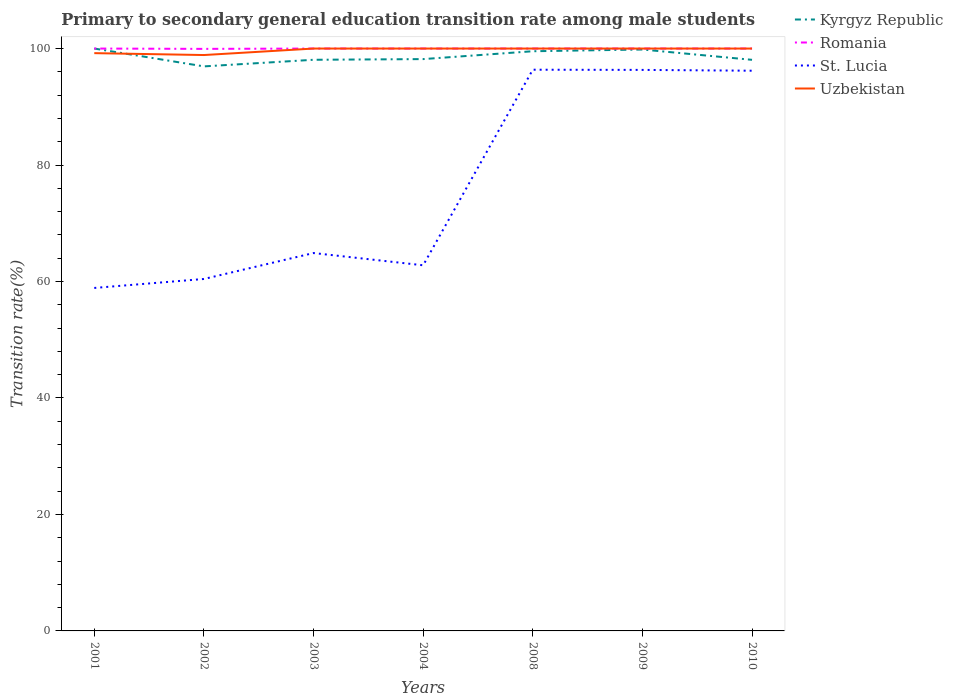Does the line corresponding to Romania intersect with the line corresponding to Kyrgyz Republic?
Give a very brief answer. Yes. Across all years, what is the maximum transition rate in Uzbekistan?
Provide a succinct answer. 98.88. In which year was the transition rate in Kyrgyz Republic maximum?
Ensure brevity in your answer.  2002. What is the total transition rate in Kyrgyz Republic in the graph?
Your answer should be very brief. 1.81. What is the difference between the highest and the second highest transition rate in Kyrgyz Republic?
Provide a short and direct response. 3.06. Is the transition rate in Uzbekistan strictly greater than the transition rate in Romania over the years?
Provide a short and direct response. No. How many lines are there?
Offer a very short reply. 4. How many years are there in the graph?
Make the answer very short. 7. Does the graph contain any zero values?
Keep it short and to the point. No. Does the graph contain grids?
Keep it short and to the point. No. Where does the legend appear in the graph?
Provide a short and direct response. Top right. How are the legend labels stacked?
Provide a short and direct response. Vertical. What is the title of the graph?
Offer a very short reply. Primary to secondary general education transition rate among male students. What is the label or title of the Y-axis?
Provide a succinct answer. Transition rate(%). What is the Transition rate(%) in Kyrgyz Republic in 2001?
Provide a short and direct response. 100. What is the Transition rate(%) in St. Lucia in 2001?
Provide a short and direct response. 58.89. What is the Transition rate(%) in Uzbekistan in 2001?
Your response must be concise. 99.21. What is the Transition rate(%) of Kyrgyz Republic in 2002?
Offer a very short reply. 96.94. What is the Transition rate(%) in Romania in 2002?
Your answer should be compact. 99.94. What is the Transition rate(%) in St. Lucia in 2002?
Provide a short and direct response. 60.43. What is the Transition rate(%) in Uzbekistan in 2002?
Give a very brief answer. 98.88. What is the Transition rate(%) in Kyrgyz Republic in 2003?
Keep it short and to the point. 98.07. What is the Transition rate(%) in Romania in 2003?
Your answer should be compact. 100. What is the Transition rate(%) of St. Lucia in 2003?
Provide a short and direct response. 64.89. What is the Transition rate(%) in Uzbekistan in 2003?
Keep it short and to the point. 100. What is the Transition rate(%) in Kyrgyz Republic in 2004?
Give a very brief answer. 98.19. What is the Transition rate(%) of Romania in 2004?
Your answer should be very brief. 100. What is the Transition rate(%) in St. Lucia in 2004?
Make the answer very short. 62.78. What is the Transition rate(%) of Uzbekistan in 2004?
Make the answer very short. 100. What is the Transition rate(%) of Kyrgyz Republic in 2008?
Your response must be concise. 99.54. What is the Transition rate(%) in St. Lucia in 2008?
Keep it short and to the point. 96.37. What is the Transition rate(%) in Uzbekistan in 2008?
Your answer should be compact. 100. What is the Transition rate(%) of Kyrgyz Republic in 2009?
Make the answer very short. 99.83. What is the Transition rate(%) of St. Lucia in 2009?
Your response must be concise. 96.33. What is the Transition rate(%) in Uzbekistan in 2009?
Your response must be concise. 100. What is the Transition rate(%) of Kyrgyz Republic in 2010?
Your answer should be compact. 98.06. What is the Transition rate(%) in Romania in 2010?
Provide a succinct answer. 100. What is the Transition rate(%) in St. Lucia in 2010?
Give a very brief answer. 96.19. What is the Transition rate(%) of Uzbekistan in 2010?
Make the answer very short. 100. Across all years, what is the maximum Transition rate(%) in Romania?
Your response must be concise. 100. Across all years, what is the maximum Transition rate(%) in St. Lucia?
Give a very brief answer. 96.37. Across all years, what is the maximum Transition rate(%) of Uzbekistan?
Your answer should be very brief. 100. Across all years, what is the minimum Transition rate(%) of Kyrgyz Republic?
Provide a short and direct response. 96.94. Across all years, what is the minimum Transition rate(%) in Romania?
Offer a very short reply. 99.94. Across all years, what is the minimum Transition rate(%) in St. Lucia?
Your answer should be compact. 58.89. Across all years, what is the minimum Transition rate(%) of Uzbekistan?
Keep it short and to the point. 98.88. What is the total Transition rate(%) in Kyrgyz Republic in the graph?
Make the answer very short. 690.63. What is the total Transition rate(%) of Romania in the graph?
Provide a succinct answer. 699.94. What is the total Transition rate(%) of St. Lucia in the graph?
Your answer should be very brief. 535.89. What is the total Transition rate(%) of Uzbekistan in the graph?
Make the answer very short. 698.1. What is the difference between the Transition rate(%) of Kyrgyz Republic in 2001 and that in 2002?
Your answer should be compact. 3.06. What is the difference between the Transition rate(%) in Romania in 2001 and that in 2002?
Your answer should be compact. 0.06. What is the difference between the Transition rate(%) in St. Lucia in 2001 and that in 2002?
Give a very brief answer. -1.54. What is the difference between the Transition rate(%) of Uzbekistan in 2001 and that in 2002?
Keep it short and to the point. 0.33. What is the difference between the Transition rate(%) in Kyrgyz Republic in 2001 and that in 2003?
Keep it short and to the point. 1.93. What is the difference between the Transition rate(%) in Romania in 2001 and that in 2003?
Your answer should be very brief. 0. What is the difference between the Transition rate(%) of St. Lucia in 2001 and that in 2003?
Provide a succinct answer. -5.99. What is the difference between the Transition rate(%) of Uzbekistan in 2001 and that in 2003?
Your response must be concise. -0.79. What is the difference between the Transition rate(%) in Kyrgyz Republic in 2001 and that in 2004?
Provide a short and direct response. 1.81. What is the difference between the Transition rate(%) of St. Lucia in 2001 and that in 2004?
Offer a very short reply. -3.89. What is the difference between the Transition rate(%) of Uzbekistan in 2001 and that in 2004?
Your response must be concise. -0.79. What is the difference between the Transition rate(%) of Kyrgyz Republic in 2001 and that in 2008?
Offer a terse response. 0.46. What is the difference between the Transition rate(%) of St. Lucia in 2001 and that in 2008?
Your answer should be compact. -37.47. What is the difference between the Transition rate(%) in Uzbekistan in 2001 and that in 2008?
Your answer should be very brief. -0.79. What is the difference between the Transition rate(%) in Kyrgyz Republic in 2001 and that in 2009?
Your answer should be very brief. 0.17. What is the difference between the Transition rate(%) in Romania in 2001 and that in 2009?
Provide a succinct answer. 0. What is the difference between the Transition rate(%) of St. Lucia in 2001 and that in 2009?
Make the answer very short. -37.44. What is the difference between the Transition rate(%) in Uzbekistan in 2001 and that in 2009?
Your answer should be compact. -0.79. What is the difference between the Transition rate(%) of Kyrgyz Republic in 2001 and that in 2010?
Offer a very short reply. 1.94. What is the difference between the Transition rate(%) in Romania in 2001 and that in 2010?
Your response must be concise. 0. What is the difference between the Transition rate(%) in St. Lucia in 2001 and that in 2010?
Offer a very short reply. -37.3. What is the difference between the Transition rate(%) of Uzbekistan in 2001 and that in 2010?
Your answer should be compact. -0.79. What is the difference between the Transition rate(%) in Kyrgyz Republic in 2002 and that in 2003?
Provide a short and direct response. -1.13. What is the difference between the Transition rate(%) of Romania in 2002 and that in 2003?
Make the answer very short. -0.06. What is the difference between the Transition rate(%) of St. Lucia in 2002 and that in 2003?
Make the answer very short. -4.45. What is the difference between the Transition rate(%) in Uzbekistan in 2002 and that in 2003?
Provide a succinct answer. -1.12. What is the difference between the Transition rate(%) in Kyrgyz Republic in 2002 and that in 2004?
Make the answer very short. -1.25. What is the difference between the Transition rate(%) in Romania in 2002 and that in 2004?
Offer a very short reply. -0.06. What is the difference between the Transition rate(%) of St. Lucia in 2002 and that in 2004?
Provide a short and direct response. -2.35. What is the difference between the Transition rate(%) in Uzbekistan in 2002 and that in 2004?
Provide a short and direct response. -1.12. What is the difference between the Transition rate(%) in Kyrgyz Republic in 2002 and that in 2008?
Offer a terse response. -2.6. What is the difference between the Transition rate(%) of Romania in 2002 and that in 2008?
Make the answer very short. -0.06. What is the difference between the Transition rate(%) in St. Lucia in 2002 and that in 2008?
Provide a succinct answer. -35.93. What is the difference between the Transition rate(%) of Uzbekistan in 2002 and that in 2008?
Give a very brief answer. -1.12. What is the difference between the Transition rate(%) in Kyrgyz Republic in 2002 and that in 2009?
Ensure brevity in your answer.  -2.9. What is the difference between the Transition rate(%) in Romania in 2002 and that in 2009?
Offer a very short reply. -0.06. What is the difference between the Transition rate(%) of St. Lucia in 2002 and that in 2009?
Provide a short and direct response. -35.9. What is the difference between the Transition rate(%) of Uzbekistan in 2002 and that in 2009?
Give a very brief answer. -1.12. What is the difference between the Transition rate(%) of Kyrgyz Republic in 2002 and that in 2010?
Ensure brevity in your answer.  -1.13. What is the difference between the Transition rate(%) in Romania in 2002 and that in 2010?
Your answer should be very brief. -0.06. What is the difference between the Transition rate(%) of St. Lucia in 2002 and that in 2010?
Keep it short and to the point. -35.76. What is the difference between the Transition rate(%) of Uzbekistan in 2002 and that in 2010?
Give a very brief answer. -1.12. What is the difference between the Transition rate(%) of Kyrgyz Republic in 2003 and that in 2004?
Make the answer very short. -0.12. What is the difference between the Transition rate(%) in Romania in 2003 and that in 2004?
Make the answer very short. 0. What is the difference between the Transition rate(%) of St. Lucia in 2003 and that in 2004?
Provide a short and direct response. 2.1. What is the difference between the Transition rate(%) in Kyrgyz Republic in 2003 and that in 2008?
Provide a short and direct response. -1.47. What is the difference between the Transition rate(%) of St. Lucia in 2003 and that in 2008?
Keep it short and to the point. -31.48. What is the difference between the Transition rate(%) in Kyrgyz Republic in 2003 and that in 2009?
Your answer should be very brief. -1.76. What is the difference between the Transition rate(%) in St. Lucia in 2003 and that in 2009?
Offer a very short reply. -31.45. What is the difference between the Transition rate(%) of Uzbekistan in 2003 and that in 2009?
Your response must be concise. 0. What is the difference between the Transition rate(%) in Kyrgyz Republic in 2003 and that in 2010?
Provide a succinct answer. 0.01. What is the difference between the Transition rate(%) of Romania in 2003 and that in 2010?
Keep it short and to the point. 0. What is the difference between the Transition rate(%) of St. Lucia in 2003 and that in 2010?
Make the answer very short. -31.31. What is the difference between the Transition rate(%) of Uzbekistan in 2003 and that in 2010?
Keep it short and to the point. 0. What is the difference between the Transition rate(%) in Kyrgyz Republic in 2004 and that in 2008?
Your answer should be very brief. -1.35. What is the difference between the Transition rate(%) in Romania in 2004 and that in 2008?
Offer a terse response. 0. What is the difference between the Transition rate(%) in St. Lucia in 2004 and that in 2008?
Offer a terse response. -33.58. What is the difference between the Transition rate(%) in Kyrgyz Republic in 2004 and that in 2009?
Your response must be concise. -1.65. What is the difference between the Transition rate(%) of St. Lucia in 2004 and that in 2009?
Your answer should be very brief. -33.55. What is the difference between the Transition rate(%) in Kyrgyz Republic in 2004 and that in 2010?
Your response must be concise. 0.12. What is the difference between the Transition rate(%) of St. Lucia in 2004 and that in 2010?
Provide a succinct answer. -33.41. What is the difference between the Transition rate(%) in Kyrgyz Republic in 2008 and that in 2009?
Offer a very short reply. -0.3. What is the difference between the Transition rate(%) in Romania in 2008 and that in 2009?
Your response must be concise. 0. What is the difference between the Transition rate(%) of St. Lucia in 2008 and that in 2009?
Keep it short and to the point. 0.03. What is the difference between the Transition rate(%) of Uzbekistan in 2008 and that in 2009?
Ensure brevity in your answer.  0. What is the difference between the Transition rate(%) in Kyrgyz Republic in 2008 and that in 2010?
Make the answer very short. 1.47. What is the difference between the Transition rate(%) of St. Lucia in 2008 and that in 2010?
Your answer should be very brief. 0.17. What is the difference between the Transition rate(%) of Uzbekistan in 2008 and that in 2010?
Offer a very short reply. 0. What is the difference between the Transition rate(%) in Kyrgyz Republic in 2009 and that in 2010?
Offer a very short reply. 1.77. What is the difference between the Transition rate(%) in St. Lucia in 2009 and that in 2010?
Keep it short and to the point. 0.14. What is the difference between the Transition rate(%) in Uzbekistan in 2009 and that in 2010?
Offer a very short reply. 0. What is the difference between the Transition rate(%) in Kyrgyz Republic in 2001 and the Transition rate(%) in Romania in 2002?
Offer a terse response. 0.06. What is the difference between the Transition rate(%) of Kyrgyz Republic in 2001 and the Transition rate(%) of St. Lucia in 2002?
Your answer should be compact. 39.57. What is the difference between the Transition rate(%) of Kyrgyz Republic in 2001 and the Transition rate(%) of Uzbekistan in 2002?
Give a very brief answer. 1.12. What is the difference between the Transition rate(%) in Romania in 2001 and the Transition rate(%) in St. Lucia in 2002?
Give a very brief answer. 39.57. What is the difference between the Transition rate(%) in Romania in 2001 and the Transition rate(%) in Uzbekistan in 2002?
Provide a short and direct response. 1.12. What is the difference between the Transition rate(%) of St. Lucia in 2001 and the Transition rate(%) of Uzbekistan in 2002?
Your answer should be very brief. -39.99. What is the difference between the Transition rate(%) of Kyrgyz Republic in 2001 and the Transition rate(%) of Romania in 2003?
Your response must be concise. 0. What is the difference between the Transition rate(%) of Kyrgyz Republic in 2001 and the Transition rate(%) of St. Lucia in 2003?
Provide a succinct answer. 35.11. What is the difference between the Transition rate(%) of Kyrgyz Republic in 2001 and the Transition rate(%) of Uzbekistan in 2003?
Provide a short and direct response. 0. What is the difference between the Transition rate(%) in Romania in 2001 and the Transition rate(%) in St. Lucia in 2003?
Make the answer very short. 35.11. What is the difference between the Transition rate(%) in Romania in 2001 and the Transition rate(%) in Uzbekistan in 2003?
Your response must be concise. 0. What is the difference between the Transition rate(%) of St. Lucia in 2001 and the Transition rate(%) of Uzbekistan in 2003?
Your response must be concise. -41.11. What is the difference between the Transition rate(%) in Kyrgyz Republic in 2001 and the Transition rate(%) in St. Lucia in 2004?
Your answer should be compact. 37.22. What is the difference between the Transition rate(%) in Kyrgyz Republic in 2001 and the Transition rate(%) in Uzbekistan in 2004?
Offer a very short reply. 0. What is the difference between the Transition rate(%) in Romania in 2001 and the Transition rate(%) in St. Lucia in 2004?
Your response must be concise. 37.22. What is the difference between the Transition rate(%) of Romania in 2001 and the Transition rate(%) of Uzbekistan in 2004?
Your response must be concise. 0. What is the difference between the Transition rate(%) of St. Lucia in 2001 and the Transition rate(%) of Uzbekistan in 2004?
Make the answer very short. -41.11. What is the difference between the Transition rate(%) in Kyrgyz Republic in 2001 and the Transition rate(%) in Romania in 2008?
Ensure brevity in your answer.  0. What is the difference between the Transition rate(%) of Kyrgyz Republic in 2001 and the Transition rate(%) of St. Lucia in 2008?
Offer a very short reply. 3.63. What is the difference between the Transition rate(%) of Kyrgyz Republic in 2001 and the Transition rate(%) of Uzbekistan in 2008?
Your answer should be compact. 0. What is the difference between the Transition rate(%) of Romania in 2001 and the Transition rate(%) of St. Lucia in 2008?
Your response must be concise. 3.63. What is the difference between the Transition rate(%) in Romania in 2001 and the Transition rate(%) in Uzbekistan in 2008?
Offer a terse response. 0. What is the difference between the Transition rate(%) of St. Lucia in 2001 and the Transition rate(%) of Uzbekistan in 2008?
Provide a short and direct response. -41.11. What is the difference between the Transition rate(%) of Kyrgyz Republic in 2001 and the Transition rate(%) of Romania in 2009?
Give a very brief answer. 0. What is the difference between the Transition rate(%) in Kyrgyz Republic in 2001 and the Transition rate(%) in St. Lucia in 2009?
Give a very brief answer. 3.67. What is the difference between the Transition rate(%) in Romania in 2001 and the Transition rate(%) in St. Lucia in 2009?
Give a very brief answer. 3.67. What is the difference between the Transition rate(%) of St. Lucia in 2001 and the Transition rate(%) of Uzbekistan in 2009?
Provide a short and direct response. -41.11. What is the difference between the Transition rate(%) in Kyrgyz Republic in 2001 and the Transition rate(%) in Romania in 2010?
Ensure brevity in your answer.  0. What is the difference between the Transition rate(%) in Kyrgyz Republic in 2001 and the Transition rate(%) in St. Lucia in 2010?
Provide a short and direct response. 3.81. What is the difference between the Transition rate(%) in Romania in 2001 and the Transition rate(%) in St. Lucia in 2010?
Your response must be concise. 3.81. What is the difference between the Transition rate(%) in St. Lucia in 2001 and the Transition rate(%) in Uzbekistan in 2010?
Your answer should be very brief. -41.11. What is the difference between the Transition rate(%) of Kyrgyz Republic in 2002 and the Transition rate(%) of Romania in 2003?
Make the answer very short. -3.06. What is the difference between the Transition rate(%) in Kyrgyz Republic in 2002 and the Transition rate(%) in St. Lucia in 2003?
Your response must be concise. 32.05. What is the difference between the Transition rate(%) in Kyrgyz Republic in 2002 and the Transition rate(%) in Uzbekistan in 2003?
Keep it short and to the point. -3.06. What is the difference between the Transition rate(%) in Romania in 2002 and the Transition rate(%) in St. Lucia in 2003?
Your response must be concise. 35.06. What is the difference between the Transition rate(%) in Romania in 2002 and the Transition rate(%) in Uzbekistan in 2003?
Your response must be concise. -0.06. What is the difference between the Transition rate(%) of St. Lucia in 2002 and the Transition rate(%) of Uzbekistan in 2003?
Give a very brief answer. -39.57. What is the difference between the Transition rate(%) in Kyrgyz Republic in 2002 and the Transition rate(%) in Romania in 2004?
Offer a very short reply. -3.06. What is the difference between the Transition rate(%) of Kyrgyz Republic in 2002 and the Transition rate(%) of St. Lucia in 2004?
Offer a terse response. 34.15. What is the difference between the Transition rate(%) in Kyrgyz Republic in 2002 and the Transition rate(%) in Uzbekistan in 2004?
Make the answer very short. -3.06. What is the difference between the Transition rate(%) of Romania in 2002 and the Transition rate(%) of St. Lucia in 2004?
Offer a very short reply. 37.16. What is the difference between the Transition rate(%) in Romania in 2002 and the Transition rate(%) in Uzbekistan in 2004?
Give a very brief answer. -0.06. What is the difference between the Transition rate(%) in St. Lucia in 2002 and the Transition rate(%) in Uzbekistan in 2004?
Your response must be concise. -39.57. What is the difference between the Transition rate(%) of Kyrgyz Republic in 2002 and the Transition rate(%) of Romania in 2008?
Ensure brevity in your answer.  -3.06. What is the difference between the Transition rate(%) in Kyrgyz Republic in 2002 and the Transition rate(%) in St. Lucia in 2008?
Offer a terse response. 0.57. What is the difference between the Transition rate(%) of Kyrgyz Republic in 2002 and the Transition rate(%) of Uzbekistan in 2008?
Offer a very short reply. -3.06. What is the difference between the Transition rate(%) in Romania in 2002 and the Transition rate(%) in St. Lucia in 2008?
Your answer should be compact. 3.58. What is the difference between the Transition rate(%) in Romania in 2002 and the Transition rate(%) in Uzbekistan in 2008?
Your response must be concise. -0.06. What is the difference between the Transition rate(%) of St. Lucia in 2002 and the Transition rate(%) of Uzbekistan in 2008?
Offer a terse response. -39.57. What is the difference between the Transition rate(%) of Kyrgyz Republic in 2002 and the Transition rate(%) of Romania in 2009?
Provide a short and direct response. -3.06. What is the difference between the Transition rate(%) in Kyrgyz Republic in 2002 and the Transition rate(%) in St. Lucia in 2009?
Provide a short and direct response. 0.6. What is the difference between the Transition rate(%) of Kyrgyz Republic in 2002 and the Transition rate(%) of Uzbekistan in 2009?
Provide a succinct answer. -3.06. What is the difference between the Transition rate(%) of Romania in 2002 and the Transition rate(%) of St. Lucia in 2009?
Offer a very short reply. 3.61. What is the difference between the Transition rate(%) in Romania in 2002 and the Transition rate(%) in Uzbekistan in 2009?
Provide a succinct answer. -0.06. What is the difference between the Transition rate(%) of St. Lucia in 2002 and the Transition rate(%) of Uzbekistan in 2009?
Your answer should be compact. -39.57. What is the difference between the Transition rate(%) of Kyrgyz Republic in 2002 and the Transition rate(%) of Romania in 2010?
Offer a very short reply. -3.06. What is the difference between the Transition rate(%) in Kyrgyz Republic in 2002 and the Transition rate(%) in St. Lucia in 2010?
Give a very brief answer. 0.74. What is the difference between the Transition rate(%) in Kyrgyz Republic in 2002 and the Transition rate(%) in Uzbekistan in 2010?
Your answer should be very brief. -3.06. What is the difference between the Transition rate(%) of Romania in 2002 and the Transition rate(%) of St. Lucia in 2010?
Your answer should be compact. 3.75. What is the difference between the Transition rate(%) of Romania in 2002 and the Transition rate(%) of Uzbekistan in 2010?
Give a very brief answer. -0.06. What is the difference between the Transition rate(%) of St. Lucia in 2002 and the Transition rate(%) of Uzbekistan in 2010?
Offer a terse response. -39.57. What is the difference between the Transition rate(%) of Kyrgyz Republic in 2003 and the Transition rate(%) of Romania in 2004?
Offer a very short reply. -1.93. What is the difference between the Transition rate(%) in Kyrgyz Republic in 2003 and the Transition rate(%) in St. Lucia in 2004?
Your response must be concise. 35.29. What is the difference between the Transition rate(%) in Kyrgyz Republic in 2003 and the Transition rate(%) in Uzbekistan in 2004?
Ensure brevity in your answer.  -1.93. What is the difference between the Transition rate(%) in Romania in 2003 and the Transition rate(%) in St. Lucia in 2004?
Offer a very short reply. 37.22. What is the difference between the Transition rate(%) of Romania in 2003 and the Transition rate(%) of Uzbekistan in 2004?
Provide a succinct answer. 0. What is the difference between the Transition rate(%) in St. Lucia in 2003 and the Transition rate(%) in Uzbekistan in 2004?
Offer a terse response. -35.11. What is the difference between the Transition rate(%) of Kyrgyz Republic in 2003 and the Transition rate(%) of Romania in 2008?
Give a very brief answer. -1.93. What is the difference between the Transition rate(%) of Kyrgyz Republic in 2003 and the Transition rate(%) of St. Lucia in 2008?
Give a very brief answer. 1.71. What is the difference between the Transition rate(%) of Kyrgyz Republic in 2003 and the Transition rate(%) of Uzbekistan in 2008?
Give a very brief answer. -1.93. What is the difference between the Transition rate(%) in Romania in 2003 and the Transition rate(%) in St. Lucia in 2008?
Keep it short and to the point. 3.63. What is the difference between the Transition rate(%) of Romania in 2003 and the Transition rate(%) of Uzbekistan in 2008?
Make the answer very short. 0. What is the difference between the Transition rate(%) in St. Lucia in 2003 and the Transition rate(%) in Uzbekistan in 2008?
Offer a terse response. -35.11. What is the difference between the Transition rate(%) of Kyrgyz Republic in 2003 and the Transition rate(%) of Romania in 2009?
Offer a terse response. -1.93. What is the difference between the Transition rate(%) of Kyrgyz Republic in 2003 and the Transition rate(%) of St. Lucia in 2009?
Ensure brevity in your answer.  1.74. What is the difference between the Transition rate(%) of Kyrgyz Republic in 2003 and the Transition rate(%) of Uzbekistan in 2009?
Ensure brevity in your answer.  -1.93. What is the difference between the Transition rate(%) in Romania in 2003 and the Transition rate(%) in St. Lucia in 2009?
Make the answer very short. 3.67. What is the difference between the Transition rate(%) in Romania in 2003 and the Transition rate(%) in Uzbekistan in 2009?
Ensure brevity in your answer.  0. What is the difference between the Transition rate(%) of St. Lucia in 2003 and the Transition rate(%) of Uzbekistan in 2009?
Make the answer very short. -35.11. What is the difference between the Transition rate(%) in Kyrgyz Republic in 2003 and the Transition rate(%) in Romania in 2010?
Offer a very short reply. -1.93. What is the difference between the Transition rate(%) of Kyrgyz Republic in 2003 and the Transition rate(%) of St. Lucia in 2010?
Give a very brief answer. 1.88. What is the difference between the Transition rate(%) in Kyrgyz Republic in 2003 and the Transition rate(%) in Uzbekistan in 2010?
Provide a succinct answer. -1.93. What is the difference between the Transition rate(%) in Romania in 2003 and the Transition rate(%) in St. Lucia in 2010?
Keep it short and to the point. 3.81. What is the difference between the Transition rate(%) in Romania in 2003 and the Transition rate(%) in Uzbekistan in 2010?
Your answer should be very brief. 0. What is the difference between the Transition rate(%) in St. Lucia in 2003 and the Transition rate(%) in Uzbekistan in 2010?
Your answer should be compact. -35.11. What is the difference between the Transition rate(%) in Kyrgyz Republic in 2004 and the Transition rate(%) in Romania in 2008?
Give a very brief answer. -1.81. What is the difference between the Transition rate(%) of Kyrgyz Republic in 2004 and the Transition rate(%) of St. Lucia in 2008?
Make the answer very short. 1.82. What is the difference between the Transition rate(%) of Kyrgyz Republic in 2004 and the Transition rate(%) of Uzbekistan in 2008?
Offer a very short reply. -1.81. What is the difference between the Transition rate(%) of Romania in 2004 and the Transition rate(%) of St. Lucia in 2008?
Your answer should be compact. 3.63. What is the difference between the Transition rate(%) in St. Lucia in 2004 and the Transition rate(%) in Uzbekistan in 2008?
Offer a terse response. -37.22. What is the difference between the Transition rate(%) in Kyrgyz Republic in 2004 and the Transition rate(%) in Romania in 2009?
Offer a terse response. -1.81. What is the difference between the Transition rate(%) in Kyrgyz Republic in 2004 and the Transition rate(%) in St. Lucia in 2009?
Ensure brevity in your answer.  1.86. What is the difference between the Transition rate(%) in Kyrgyz Republic in 2004 and the Transition rate(%) in Uzbekistan in 2009?
Provide a succinct answer. -1.81. What is the difference between the Transition rate(%) in Romania in 2004 and the Transition rate(%) in St. Lucia in 2009?
Keep it short and to the point. 3.67. What is the difference between the Transition rate(%) of St. Lucia in 2004 and the Transition rate(%) of Uzbekistan in 2009?
Your answer should be compact. -37.22. What is the difference between the Transition rate(%) in Kyrgyz Republic in 2004 and the Transition rate(%) in Romania in 2010?
Provide a short and direct response. -1.81. What is the difference between the Transition rate(%) of Kyrgyz Republic in 2004 and the Transition rate(%) of St. Lucia in 2010?
Offer a very short reply. 2. What is the difference between the Transition rate(%) of Kyrgyz Republic in 2004 and the Transition rate(%) of Uzbekistan in 2010?
Your answer should be compact. -1.81. What is the difference between the Transition rate(%) in Romania in 2004 and the Transition rate(%) in St. Lucia in 2010?
Make the answer very short. 3.81. What is the difference between the Transition rate(%) of St. Lucia in 2004 and the Transition rate(%) of Uzbekistan in 2010?
Your response must be concise. -37.22. What is the difference between the Transition rate(%) in Kyrgyz Republic in 2008 and the Transition rate(%) in Romania in 2009?
Give a very brief answer. -0.46. What is the difference between the Transition rate(%) in Kyrgyz Republic in 2008 and the Transition rate(%) in St. Lucia in 2009?
Provide a short and direct response. 3.2. What is the difference between the Transition rate(%) of Kyrgyz Republic in 2008 and the Transition rate(%) of Uzbekistan in 2009?
Give a very brief answer. -0.46. What is the difference between the Transition rate(%) in Romania in 2008 and the Transition rate(%) in St. Lucia in 2009?
Offer a terse response. 3.67. What is the difference between the Transition rate(%) of Romania in 2008 and the Transition rate(%) of Uzbekistan in 2009?
Your answer should be very brief. 0. What is the difference between the Transition rate(%) of St. Lucia in 2008 and the Transition rate(%) of Uzbekistan in 2009?
Your answer should be very brief. -3.63. What is the difference between the Transition rate(%) of Kyrgyz Republic in 2008 and the Transition rate(%) of Romania in 2010?
Your response must be concise. -0.46. What is the difference between the Transition rate(%) in Kyrgyz Republic in 2008 and the Transition rate(%) in St. Lucia in 2010?
Your answer should be very brief. 3.34. What is the difference between the Transition rate(%) in Kyrgyz Republic in 2008 and the Transition rate(%) in Uzbekistan in 2010?
Offer a terse response. -0.46. What is the difference between the Transition rate(%) in Romania in 2008 and the Transition rate(%) in St. Lucia in 2010?
Your response must be concise. 3.81. What is the difference between the Transition rate(%) in St. Lucia in 2008 and the Transition rate(%) in Uzbekistan in 2010?
Give a very brief answer. -3.63. What is the difference between the Transition rate(%) in Kyrgyz Republic in 2009 and the Transition rate(%) in Romania in 2010?
Provide a short and direct response. -0.17. What is the difference between the Transition rate(%) of Kyrgyz Republic in 2009 and the Transition rate(%) of St. Lucia in 2010?
Keep it short and to the point. 3.64. What is the difference between the Transition rate(%) of Kyrgyz Republic in 2009 and the Transition rate(%) of Uzbekistan in 2010?
Ensure brevity in your answer.  -0.17. What is the difference between the Transition rate(%) of Romania in 2009 and the Transition rate(%) of St. Lucia in 2010?
Your answer should be compact. 3.81. What is the difference between the Transition rate(%) of Romania in 2009 and the Transition rate(%) of Uzbekistan in 2010?
Offer a very short reply. 0. What is the difference between the Transition rate(%) in St. Lucia in 2009 and the Transition rate(%) in Uzbekistan in 2010?
Provide a short and direct response. -3.67. What is the average Transition rate(%) in Kyrgyz Republic per year?
Keep it short and to the point. 98.66. What is the average Transition rate(%) in Romania per year?
Your response must be concise. 99.99. What is the average Transition rate(%) of St. Lucia per year?
Your answer should be compact. 76.56. What is the average Transition rate(%) in Uzbekistan per year?
Give a very brief answer. 99.73. In the year 2001, what is the difference between the Transition rate(%) of Kyrgyz Republic and Transition rate(%) of St. Lucia?
Provide a succinct answer. 41.11. In the year 2001, what is the difference between the Transition rate(%) in Kyrgyz Republic and Transition rate(%) in Uzbekistan?
Make the answer very short. 0.79. In the year 2001, what is the difference between the Transition rate(%) of Romania and Transition rate(%) of St. Lucia?
Offer a terse response. 41.11. In the year 2001, what is the difference between the Transition rate(%) in Romania and Transition rate(%) in Uzbekistan?
Keep it short and to the point. 0.79. In the year 2001, what is the difference between the Transition rate(%) in St. Lucia and Transition rate(%) in Uzbekistan?
Offer a terse response. -40.32. In the year 2002, what is the difference between the Transition rate(%) in Kyrgyz Republic and Transition rate(%) in Romania?
Offer a very short reply. -3.01. In the year 2002, what is the difference between the Transition rate(%) of Kyrgyz Republic and Transition rate(%) of St. Lucia?
Keep it short and to the point. 36.5. In the year 2002, what is the difference between the Transition rate(%) in Kyrgyz Republic and Transition rate(%) in Uzbekistan?
Ensure brevity in your answer.  -1.95. In the year 2002, what is the difference between the Transition rate(%) of Romania and Transition rate(%) of St. Lucia?
Make the answer very short. 39.51. In the year 2002, what is the difference between the Transition rate(%) in Romania and Transition rate(%) in Uzbekistan?
Provide a short and direct response. 1.06. In the year 2002, what is the difference between the Transition rate(%) of St. Lucia and Transition rate(%) of Uzbekistan?
Give a very brief answer. -38.45. In the year 2003, what is the difference between the Transition rate(%) of Kyrgyz Republic and Transition rate(%) of Romania?
Your response must be concise. -1.93. In the year 2003, what is the difference between the Transition rate(%) of Kyrgyz Republic and Transition rate(%) of St. Lucia?
Provide a short and direct response. 33.19. In the year 2003, what is the difference between the Transition rate(%) of Kyrgyz Republic and Transition rate(%) of Uzbekistan?
Offer a terse response. -1.93. In the year 2003, what is the difference between the Transition rate(%) in Romania and Transition rate(%) in St. Lucia?
Your response must be concise. 35.11. In the year 2003, what is the difference between the Transition rate(%) in St. Lucia and Transition rate(%) in Uzbekistan?
Offer a very short reply. -35.11. In the year 2004, what is the difference between the Transition rate(%) in Kyrgyz Republic and Transition rate(%) in Romania?
Your answer should be very brief. -1.81. In the year 2004, what is the difference between the Transition rate(%) of Kyrgyz Republic and Transition rate(%) of St. Lucia?
Provide a short and direct response. 35.4. In the year 2004, what is the difference between the Transition rate(%) of Kyrgyz Republic and Transition rate(%) of Uzbekistan?
Keep it short and to the point. -1.81. In the year 2004, what is the difference between the Transition rate(%) in Romania and Transition rate(%) in St. Lucia?
Ensure brevity in your answer.  37.22. In the year 2004, what is the difference between the Transition rate(%) of Romania and Transition rate(%) of Uzbekistan?
Offer a very short reply. 0. In the year 2004, what is the difference between the Transition rate(%) of St. Lucia and Transition rate(%) of Uzbekistan?
Offer a very short reply. -37.22. In the year 2008, what is the difference between the Transition rate(%) in Kyrgyz Republic and Transition rate(%) in Romania?
Your answer should be compact. -0.46. In the year 2008, what is the difference between the Transition rate(%) in Kyrgyz Republic and Transition rate(%) in St. Lucia?
Ensure brevity in your answer.  3.17. In the year 2008, what is the difference between the Transition rate(%) in Kyrgyz Republic and Transition rate(%) in Uzbekistan?
Provide a succinct answer. -0.46. In the year 2008, what is the difference between the Transition rate(%) of Romania and Transition rate(%) of St. Lucia?
Keep it short and to the point. 3.63. In the year 2008, what is the difference between the Transition rate(%) in St. Lucia and Transition rate(%) in Uzbekistan?
Make the answer very short. -3.63. In the year 2009, what is the difference between the Transition rate(%) of Kyrgyz Republic and Transition rate(%) of Romania?
Your answer should be very brief. -0.17. In the year 2009, what is the difference between the Transition rate(%) of Kyrgyz Republic and Transition rate(%) of St. Lucia?
Your answer should be compact. 3.5. In the year 2009, what is the difference between the Transition rate(%) of Kyrgyz Republic and Transition rate(%) of Uzbekistan?
Ensure brevity in your answer.  -0.17. In the year 2009, what is the difference between the Transition rate(%) of Romania and Transition rate(%) of St. Lucia?
Make the answer very short. 3.67. In the year 2009, what is the difference between the Transition rate(%) of Romania and Transition rate(%) of Uzbekistan?
Ensure brevity in your answer.  0. In the year 2009, what is the difference between the Transition rate(%) of St. Lucia and Transition rate(%) of Uzbekistan?
Offer a terse response. -3.67. In the year 2010, what is the difference between the Transition rate(%) in Kyrgyz Republic and Transition rate(%) in Romania?
Ensure brevity in your answer.  -1.94. In the year 2010, what is the difference between the Transition rate(%) of Kyrgyz Republic and Transition rate(%) of St. Lucia?
Provide a short and direct response. 1.87. In the year 2010, what is the difference between the Transition rate(%) in Kyrgyz Republic and Transition rate(%) in Uzbekistan?
Your answer should be compact. -1.94. In the year 2010, what is the difference between the Transition rate(%) in Romania and Transition rate(%) in St. Lucia?
Make the answer very short. 3.81. In the year 2010, what is the difference between the Transition rate(%) in Romania and Transition rate(%) in Uzbekistan?
Provide a short and direct response. 0. In the year 2010, what is the difference between the Transition rate(%) of St. Lucia and Transition rate(%) of Uzbekistan?
Your response must be concise. -3.81. What is the ratio of the Transition rate(%) in Kyrgyz Republic in 2001 to that in 2002?
Make the answer very short. 1.03. What is the ratio of the Transition rate(%) in St. Lucia in 2001 to that in 2002?
Provide a short and direct response. 0.97. What is the ratio of the Transition rate(%) of Uzbekistan in 2001 to that in 2002?
Your answer should be compact. 1. What is the ratio of the Transition rate(%) in Kyrgyz Republic in 2001 to that in 2003?
Your response must be concise. 1.02. What is the ratio of the Transition rate(%) of Romania in 2001 to that in 2003?
Offer a terse response. 1. What is the ratio of the Transition rate(%) in St. Lucia in 2001 to that in 2003?
Your answer should be compact. 0.91. What is the ratio of the Transition rate(%) in Kyrgyz Republic in 2001 to that in 2004?
Give a very brief answer. 1.02. What is the ratio of the Transition rate(%) in Romania in 2001 to that in 2004?
Give a very brief answer. 1. What is the ratio of the Transition rate(%) of St. Lucia in 2001 to that in 2004?
Provide a short and direct response. 0.94. What is the ratio of the Transition rate(%) of Romania in 2001 to that in 2008?
Your response must be concise. 1. What is the ratio of the Transition rate(%) in St. Lucia in 2001 to that in 2008?
Provide a short and direct response. 0.61. What is the ratio of the Transition rate(%) of St. Lucia in 2001 to that in 2009?
Your answer should be very brief. 0.61. What is the ratio of the Transition rate(%) in Uzbekistan in 2001 to that in 2009?
Give a very brief answer. 0.99. What is the ratio of the Transition rate(%) of Kyrgyz Republic in 2001 to that in 2010?
Give a very brief answer. 1.02. What is the ratio of the Transition rate(%) in Romania in 2001 to that in 2010?
Offer a very short reply. 1. What is the ratio of the Transition rate(%) in St. Lucia in 2001 to that in 2010?
Your answer should be very brief. 0.61. What is the ratio of the Transition rate(%) of Uzbekistan in 2001 to that in 2010?
Give a very brief answer. 0.99. What is the ratio of the Transition rate(%) in Kyrgyz Republic in 2002 to that in 2003?
Your answer should be very brief. 0.99. What is the ratio of the Transition rate(%) in St. Lucia in 2002 to that in 2003?
Your answer should be very brief. 0.93. What is the ratio of the Transition rate(%) in Uzbekistan in 2002 to that in 2003?
Offer a very short reply. 0.99. What is the ratio of the Transition rate(%) in Kyrgyz Republic in 2002 to that in 2004?
Give a very brief answer. 0.99. What is the ratio of the Transition rate(%) in St. Lucia in 2002 to that in 2004?
Make the answer very short. 0.96. What is the ratio of the Transition rate(%) in Kyrgyz Republic in 2002 to that in 2008?
Ensure brevity in your answer.  0.97. What is the ratio of the Transition rate(%) of St. Lucia in 2002 to that in 2008?
Ensure brevity in your answer.  0.63. What is the ratio of the Transition rate(%) of Uzbekistan in 2002 to that in 2008?
Provide a succinct answer. 0.99. What is the ratio of the Transition rate(%) of Kyrgyz Republic in 2002 to that in 2009?
Your answer should be very brief. 0.97. What is the ratio of the Transition rate(%) in St. Lucia in 2002 to that in 2009?
Provide a short and direct response. 0.63. What is the ratio of the Transition rate(%) in Kyrgyz Republic in 2002 to that in 2010?
Offer a very short reply. 0.99. What is the ratio of the Transition rate(%) of St. Lucia in 2002 to that in 2010?
Offer a very short reply. 0.63. What is the ratio of the Transition rate(%) in St. Lucia in 2003 to that in 2004?
Provide a succinct answer. 1.03. What is the ratio of the Transition rate(%) of Uzbekistan in 2003 to that in 2004?
Ensure brevity in your answer.  1. What is the ratio of the Transition rate(%) of St. Lucia in 2003 to that in 2008?
Your answer should be very brief. 0.67. What is the ratio of the Transition rate(%) in Kyrgyz Republic in 2003 to that in 2009?
Provide a short and direct response. 0.98. What is the ratio of the Transition rate(%) of St. Lucia in 2003 to that in 2009?
Make the answer very short. 0.67. What is the ratio of the Transition rate(%) of Uzbekistan in 2003 to that in 2009?
Your answer should be very brief. 1. What is the ratio of the Transition rate(%) in St. Lucia in 2003 to that in 2010?
Make the answer very short. 0.67. What is the ratio of the Transition rate(%) of Uzbekistan in 2003 to that in 2010?
Your answer should be compact. 1. What is the ratio of the Transition rate(%) of Kyrgyz Republic in 2004 to that in 2008?
Ensure brevity in your answer.  0.99. What is the ratio of the Transition rate(%) in Romania in 2004 to that in 2008?
Keep it short and to the point. 1. What is the ratio of the Transition rate(%) of St. Lucia in 2004 to that in 2008?
Your answer should be compact. 0.65. What is the ratio of the Transition rate(%) of Uzbekistan in 2004 to that in 2008?
Give a very brief answer. 1. What is the ratio of the Transition rate(%) of Kyrgyz Republic in 2004 to that in 2009?
Make the answer very short. 0.98. What is the ratio of the Transition rate(%) in Romania in 2004 to that in 2009?
Ensure brevity in your answer.  1. What is the ratio of the Transition rate(%) of St. Lucia in 2004 to that in 2009?
Your answer should be very brief. 0.65. What is the ratio of the Transition rate(%) in Romania in 2004 to that in 2010?
Give a very brief answer. 1. What is the ratio of the Transition rate(%) in St. Lucia in 2004 to that in 2010?
Provide a short and direct response. 0.65. What is the ratio of the Transition rate(%) of Kyrgyz Republic in 2008 to that in 2009?
Make the answer very short. 1. What is the ratio of the Transition rate(%) in Kyrgyz Republic in 2008 to that in 2010?
Offer a terse response. 1.01. What is the ratio of the Transition rate(%) of Uzbekistan in 2008 to that in 2010?
Ensure brevity in your answer.  1. What is the ratio of the Transition rate(%) of Uzbekistan in 2009 to that in 2010?
Your response must be concise. 1. What is the difference between the highest and the second highest Transition rate(%) of Kyrgyz Republic?
Keep it short and to the point. 0.17. What is the difference between the highest and the second highest Transition rate(%) of St. Lucia?
Provide a short and direct response. 0.03. What is the difference between the highest and the second highest Transition rate(%) in Uzbekistan?
Offer a terse response. 0. What is the difference between the highest and the lowest Transition rate(%) in Kyrgyz Republic?
Your response must be concise. 3.06. What is the difference between the highest and the lowest Transition rate(%) of Romania?
Your answer should be compact. 0.06. What is the difference between the highest and the lowest Transition rate(%) of St. Lucia?
Your response must be concise. 37.47. What is the difference between the highest and the lowest Transition rate(%) of Uzbekistan?
Provide a short and direct response. 1.12. 